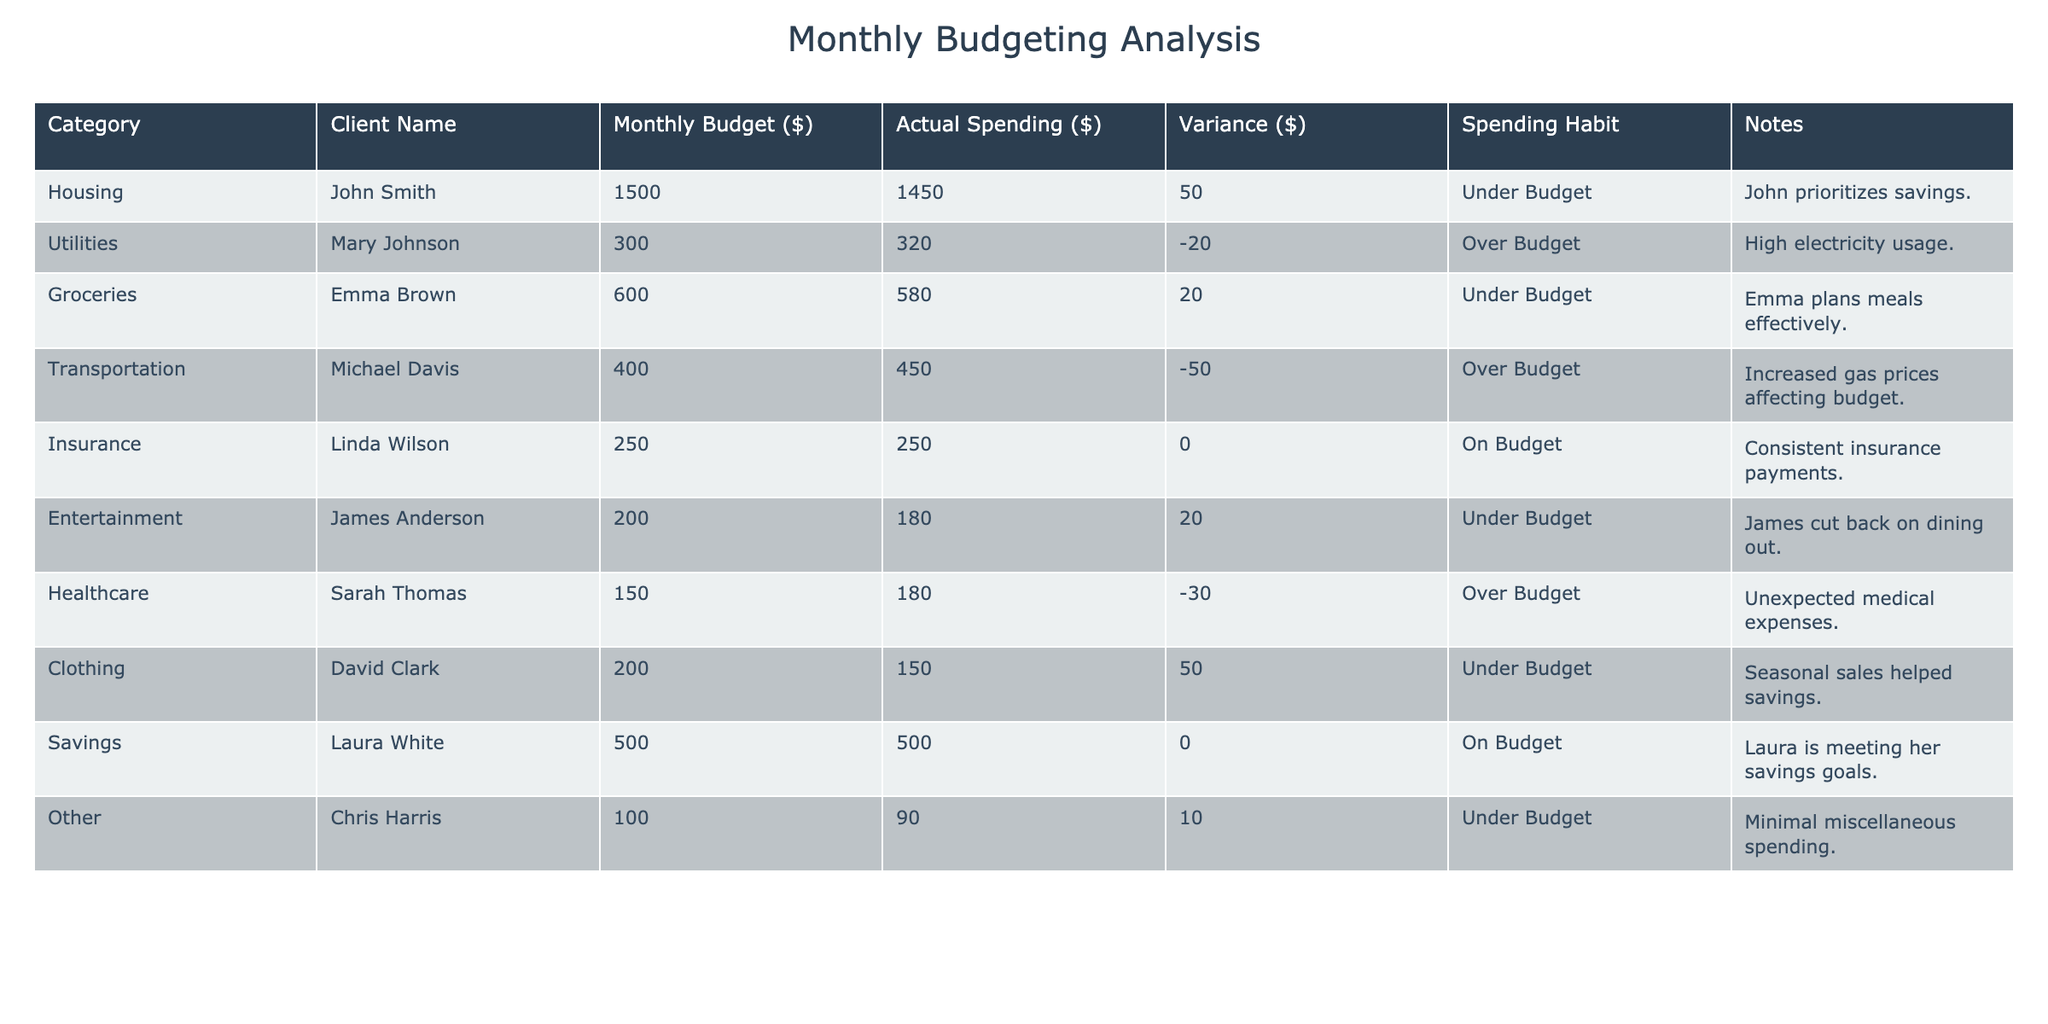What is the budgeted amount for groceries for Emma Brown? Looking at the "Monthly Budget ($)" column for the row where the "Client Name" is Emma Brown, it shows that the budgeted amount is 600.
Answer: 600 What was the actual spending for housing by John Smith? In the row for John Smith under the "Actual Spending ($)" column, the value given is 1450.
Answer: 1450 Is Linda Wilson on budget for insurance? The row for Linda Wilson indicates she spent exactly what she budgeted, which is reflected in her "Variance ($)" as 0. This means she is on budget.
Answer: Yes What is the total variance in spending across all clients? To find the total variance, we sum the "Variance ($)" values: 50 + (-20) + 20 + (-50) + 0 + 20 + (-30) + 50 + 0 + 10 = 0. Thus, the total variance is 0, indicating a balanced approach overall.
Answer: 0 Which client had the highest over budget amount and what is that amount? Checking the "Variance ($)" column, the maximum negative value indicates the highest over budget amount. Michael Davis has a variance of -50, which is the highest over budget amount among the clients.
Answer: -50 What percentage of the budget did Emma Brown spend on groceries? We calculate the percentage by dividing the actual spending (580) by the budgeted amount (600) and then multiplying by 100: (580/600) * 100 = 96.67%. Therefore, Emma spent approximately 96.67% of her budget on groceries.
Answer: 96.67% How many clients spent less than their budget? By checking each client's "Spending Habit," we see that John Smith, Emma Brown, James Anderson, David Clark, and Chris Harris spent under budget, giving us a total of 5 clients.
Answer: 5 Is there any client that has both budgeted and actual amounts equal? By examining the table, we note that Linda Wilson and Laura White both have "Budget ($)" equal to "Actual Spending ($)" which results in a variance of 0.
Answer: Yes What is the average actual spending for all clients? To find the average, we sum all actual spending values (1450 + 320 + 580 + 450 + 250 + 180 + 180 + 150 + 500 + 90 = 3120) and divide by the number of clients (10): 3120 / 10 = 312. Therefore, the average actual spending is 312.
Answer: 312 